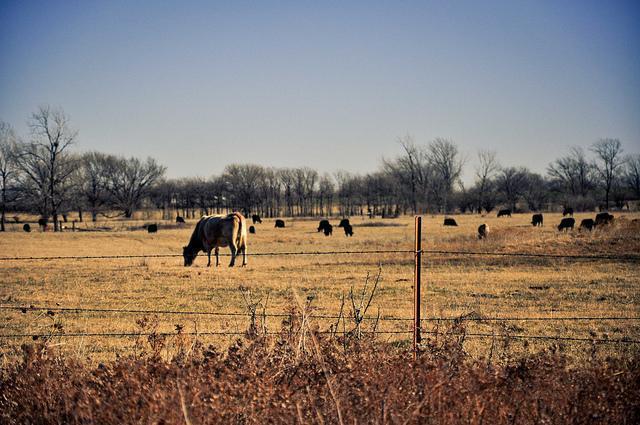How many fence posts are there?
Give a very brief answer. 1. How many birds on the wire?
Give a very brief answer. 0. 